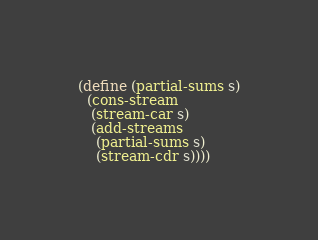Convert code to text. <code><loc_0><loc_0><loc_500><loc_500><_Scheme_>(define (partial-sums s)
  (cons-stream
   (stream-car s)
   (add-streams
    (partial-sums s)
    (stream-cdr s))))
</code> 